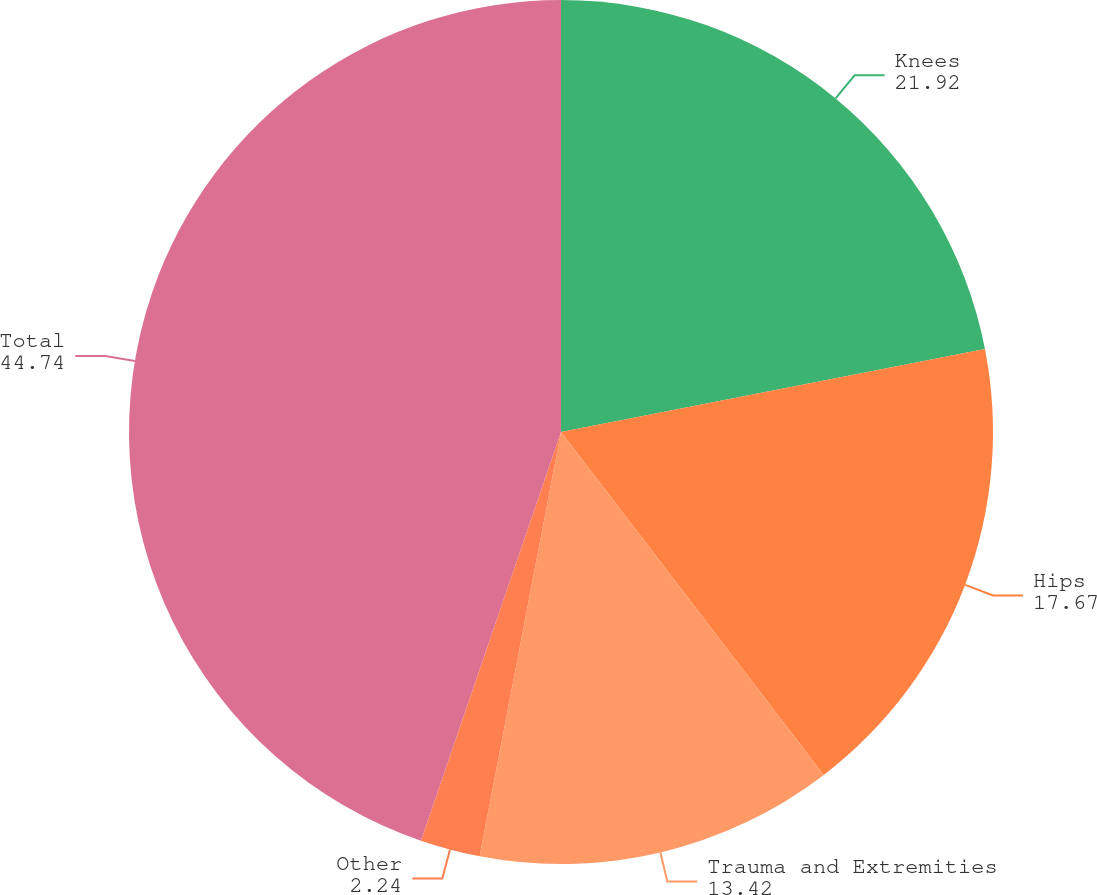Convert chart to OTSL. <chart><loc_0><loc_0><loc_500><loc_500><pie_chart><fcel>Knees<fcel>Hips<fcel>Trauma and Extremities<fcel>Other<fcel>Total<nl><fcel>21.92%<fcel>17.67%<fcel>13.42%<fcel>2.24%<fcel>44.74%<nl></chart> 